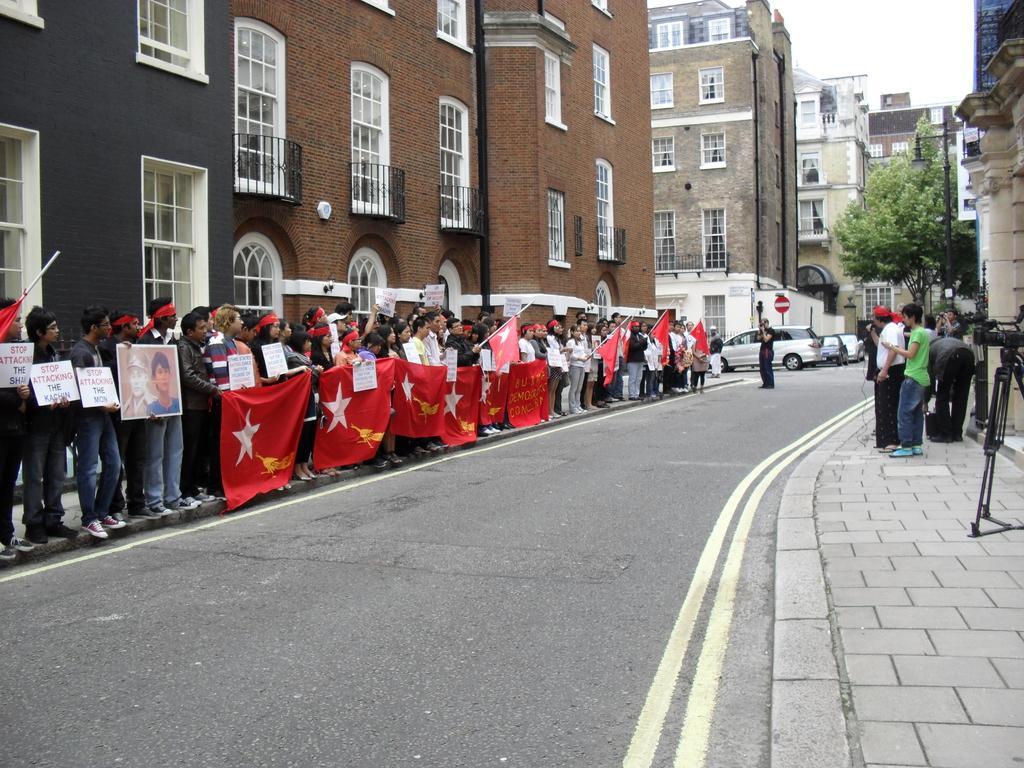Please provide a concise description of this image. The picture is taken outside a city, on the streets. On the right side there are buildings, trees, poles, people, stand and pavement. In the center of the picture there is road, cars and buildings. On the right there are people standing holding flag and placards on the pavement, behind them there are buildings, windows and doors. Sky is cloudy. 